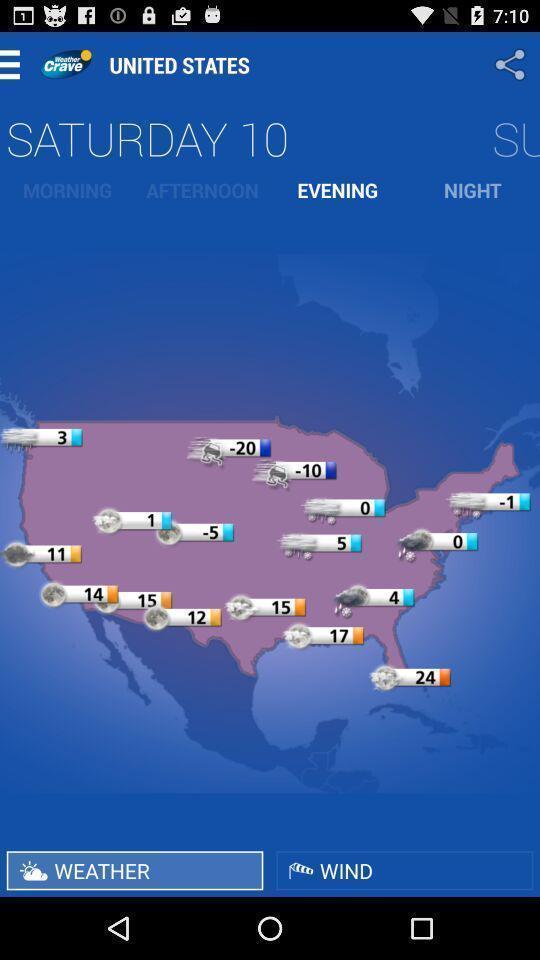What can you discern from this picture? Screen shows information about weather. 